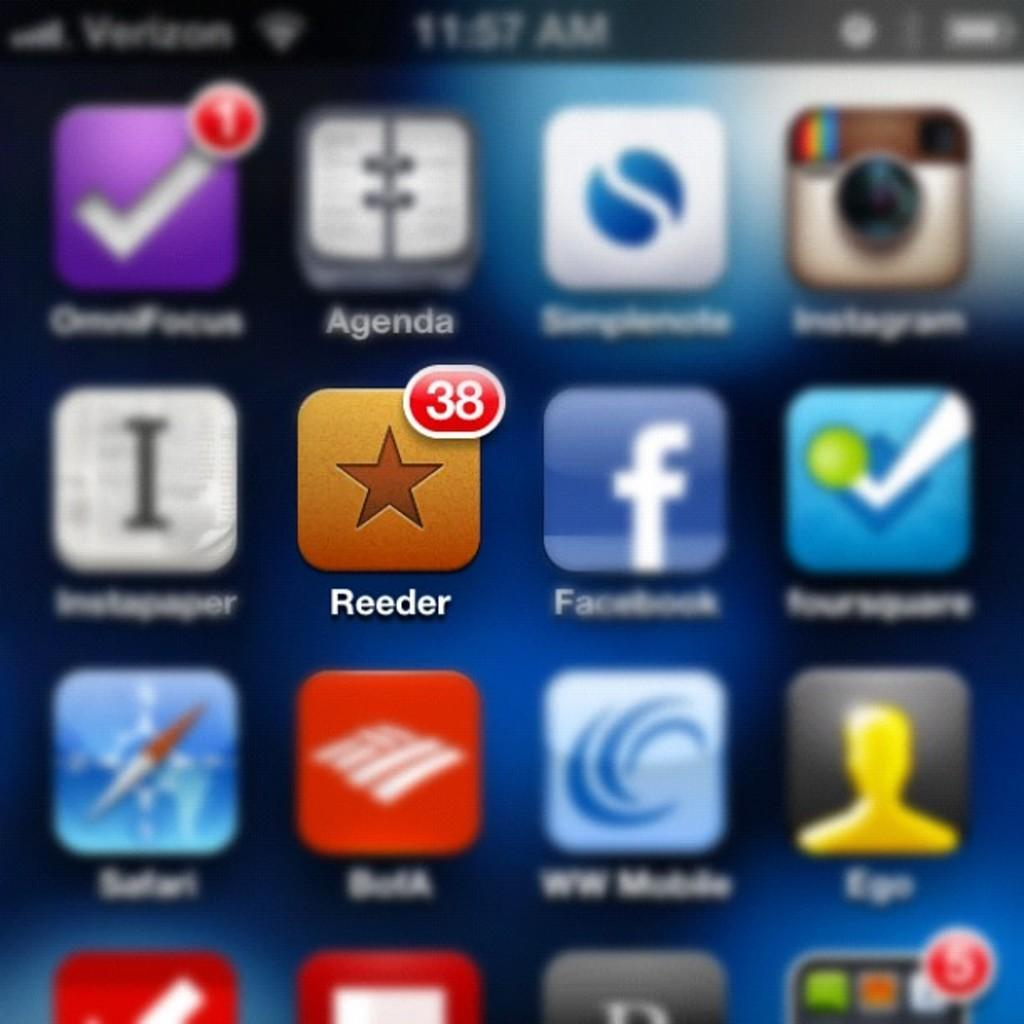Provide a one-sentence caption for the provided image. A phone displaying lots of apps with the Reeder app in the forefront. 